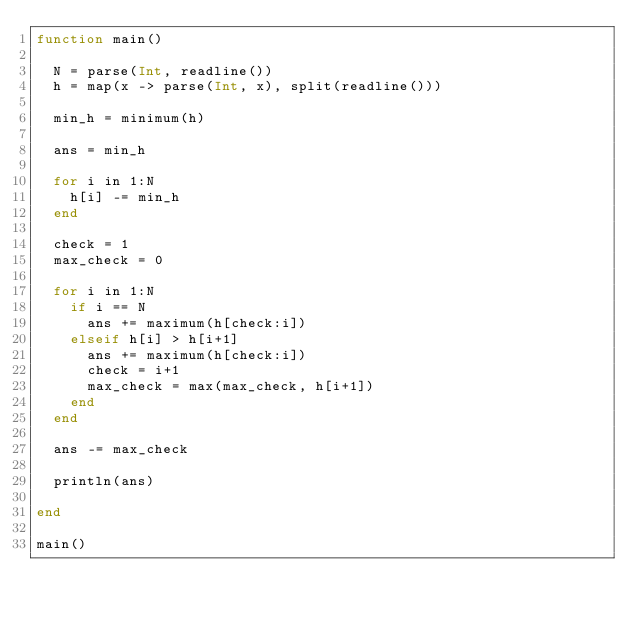<code> <loc_0><loc_0><loc_500><loc_500><_Julia_>function main()
  
  N = parse(Int, readline())
  h = map(x -> parse(Int, x), split(readline()))
  
  min_h = minimum(h)
  
  ans = min_h
  
  for i in 1:N
    h[i] -= min_h
  end
  
  check = 1
  max_check = 0
  
  for i in 1:N
    if i == N
      ans += maximum(h[check:i])
    elseif h[i] > h[i+1]
      ans += maximum(h[check:i])
      check = i+1
      max_check = max(max_check, h[i+1])
    end
  end
  
  ans -= max_check
  
  println(ans)
  
end

main()</code> 